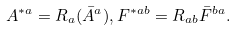Convert formula to latex. <formula><loc_0><loc_0><loc_500><loc_500>A ^ { * a } = R _ { a } ( \bar { A } ^ { a } ) , F ^ { * a b } = R _ { a b } \bar { F } ^ { b a } .</formula> 